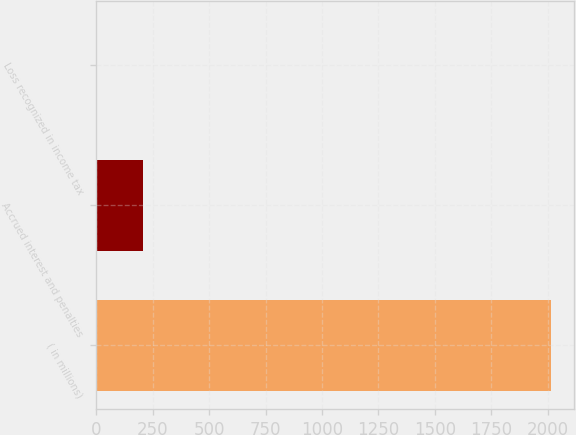Convert chart to OTSL. <chart><loc_0><loc_0><loc_500><loc_500><bar_chart><fcel>( in millions)<fcel>Accrued interest and penalties<fcel>Loss recognized in income tax<nl><fcel>2017<fcel>205.3<fcel>4<nl></chart> 